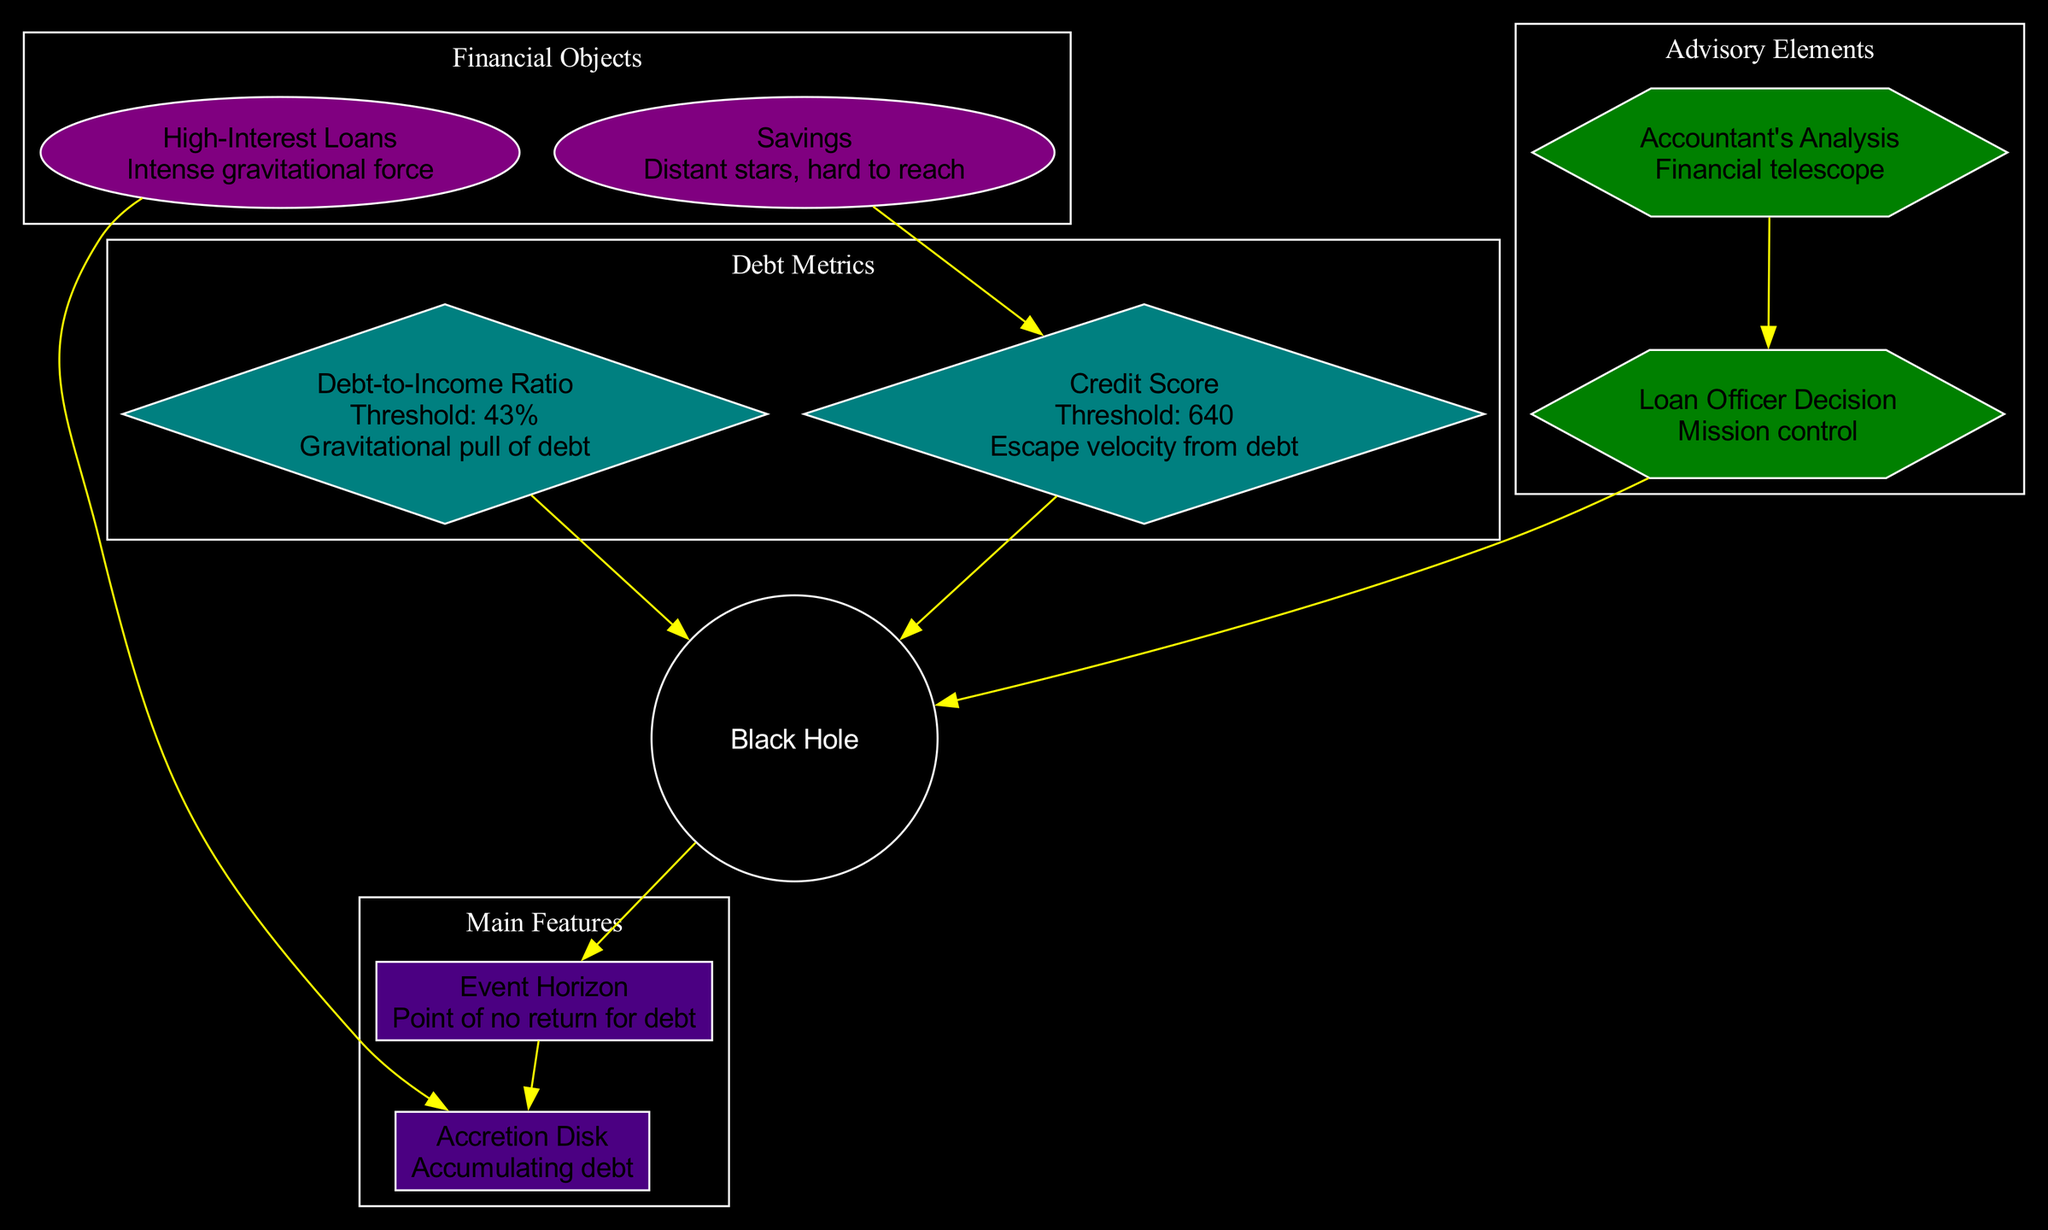What is the threshold for the Debt-to-Income Ratio? The diagram clearly states that the threshold for the Debt-to-Income Ratio is indicated next to the node labeled "Debt-to-Income Ratio," which reads "Threshold: 43%".
Answer: 43% What does the Event Horizon represent? In the diagram, the Event Horizon is associated with the description "Point of no return for debt," indicating the concept of reaching a critical financial point related to debt management.
Answer: Point of no return for debt Which financial object is linked to Accumulating debt? By tracing the edges from the main features in the diagram, it is evident that "High-Interest Loans," which is a financial object, has a direct connection with "Accretion Disk," emphasizing accumulating debt.
Answer: High-Interest Loans What color is associated with the Credit Score node? The Credit Score node's color can be identified in the diagram, which has a diamond shape and is filled with a specific shade, consistent with the color scheme defined for debt metrics. The color for these is #008080.
Answer: Teal How many main features are there in the diagram? By counting the nodes under the "Main Features" section of the diagram, it shows there are two nodes listed: "Event Horizon" and "Accretion Disk."
Answer: 2 What does the Accountant's Analysis serve as in this diagram? The diagram describes "Accountant's Analysis" as a "Financial telescope," indicating its role in providing clarity and insight into financial situations related to debts and loans assessments.
Answer: Financial telescope Which node represents the escape velocity from debt? The diagram explicitly states that the node labeled "Credit Score" has the description "Escape velocity from debt," which clearly indicates its significance in overcoming financial obstacles.
Answer: Credit Score What is the relationship between Savings and Credit Score? A directed edge in the diagram connects "Savings" to "Credit Score," which implies that there is a supportive relationship; savings can positively impact one's credit score.
Answer: Savings to Credit Score What is the main role of the Loan Officer Decision node? In the diagram, "Loan Officer Decision" is described as "Mission control," suggesting it plays a crucial role in overseeing and guiding the loan approval process based on provided analyses.
Answer: Mission control 